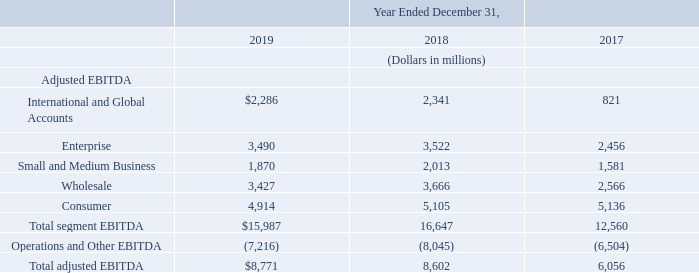Reconciliation of segment EBITDA to total adjusted EBITDA is below:
For additional information on our reportable segments and product and services categories, see Note 17— Segment Information to our consolidated financial statements in Item 8 of Part II of this report.
What additional information does Note 17 provide? Additional information on our reportable segments and product and services categories. What is the total adjusted EBITDA in 2019?
Answer scale should be: million. $8,771. What are the segments under Adjusted EBITDA? International and global accounts, enterprise, small and medium business, wholesale, consumer. How many segments are there under Adjusted EBITDA? International and Global Accounts##Enterprise##Small and Medium Business##Wholesale##Consumer
Answer: 5. What is the change in the adjusted EBITDA under Wholesale in 2019 from 2018?
Answer scale should be: million. 3,427-3,666
Answer: -239. What is the average total adjusted EBITDA over the three years?
Answer scale should be: million. (8,771+8,602+6,056)/3
Answer: 7809.67. 